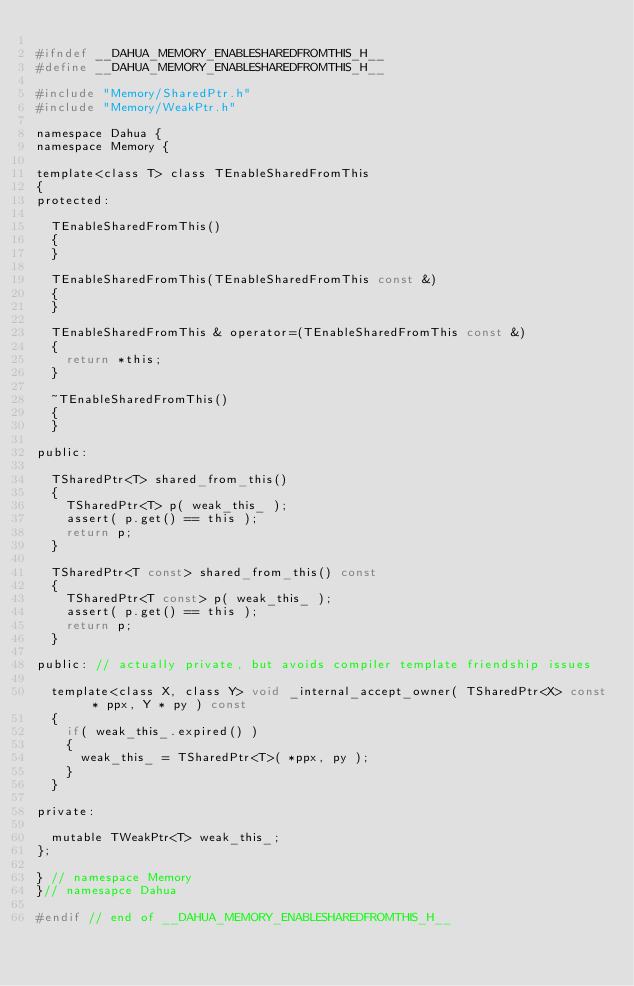<code> <loc_0><loc_0><loc_500><loc_500><_C_>
#ifndef __DAHUA_MEMORY_ENABLESHAREDFROMTHIS_H__
#define __DAHUA_MEMORY_ENABLESHAREDFROMTHIS_H__

#include "Memory/SharedPtr.h"
#include "Memory/WeakPtr.h"

namespace Dahua {
namespace Memory {

template<class T> class TEnableSharedFromThis
{
protected:
	
	TEnableSharedFromThis() 
	{
	}

	TEnableSharedFromThis(TEnableSharedFromThis const &)
	{
	}

	TEnableSharedFromThis & operator=(TEnableSharedFromThis const &)
	{
		return *this;
	}

	~TEnableSharedFromThis()
	{
	}

public:

	TSharedPtr<T> shared_from_this()
	{
		TSharedPtr<T> p( weak_this_ );
		assert( p.get() == this );
		return p;
	}

	TSharedPtr<T const> shared_from_this() const
	{
		TSharedPtr<T const> p( weak_this_ );
		assert( p.get() == this );
		return p;
	}

public: // actually private, but avoids compiler template friendship issues

	template<class X, class Y> void _internal_accept_owner( TSharedPtr<X> const * ppx, Y * py ) const
	{
		if( weak_this_.expired() )
		{
			weak_this_ = TSharedPtr<T>( *ppx, py );
		}
	}

private:

	mutable TWeakPtr<T> weak_this_;
};

} // namespace Memory
}// namesapce Dahua

#endif // end of __DAHUA_MEMORY_ENABLESHAREDFROMTHIS_H__

</code> 